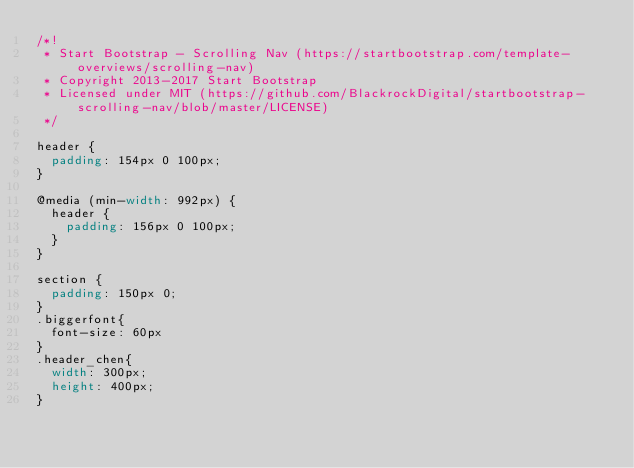Convert code to text. <code><loc_0><loc_0><loc_500><loc_500><_CSS_>/*!
 * Start Bootstrap - Scrolling Nav (https://startbootstrap.com/template-overviews/scrolling-nav)
 * Copyright 2013-2017 Start Bootstrap
 * Licensed under MIT (https://github.com/BlackrockDigital/startbootstrap-scrolling-nav/blob/master/LICENSE)
 */

header {
  padding: 154px 0 100px;
}

@media (min-width: 992px) {
  header {
    padding: 156px 0 100px;
  }
}

section {
  padding: 150px 0;
}
.biggerfont{
  font-size: 60px
}
.header_chen{
  width: 300px; 
  height: 400px;
}

</code> 